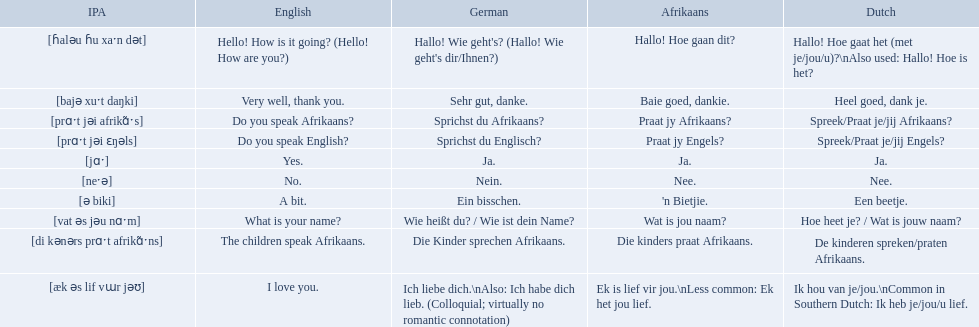What are all of the afrikaans phrases shown in the table? Hallo! Hoe gaan dit?, Baie goed, dankie., Praat jy Afrikaans?, Praat jy Engels?, Ja., Nee., 'n Bietjie., Wat is jou naam?, Die kinders praat Afrikaans., Ek is lief vir jou.\nLess common: Ek het jou lief. Of those, which translates into english as do you speak afrikaans?? Praat jy Afrikaans?. 